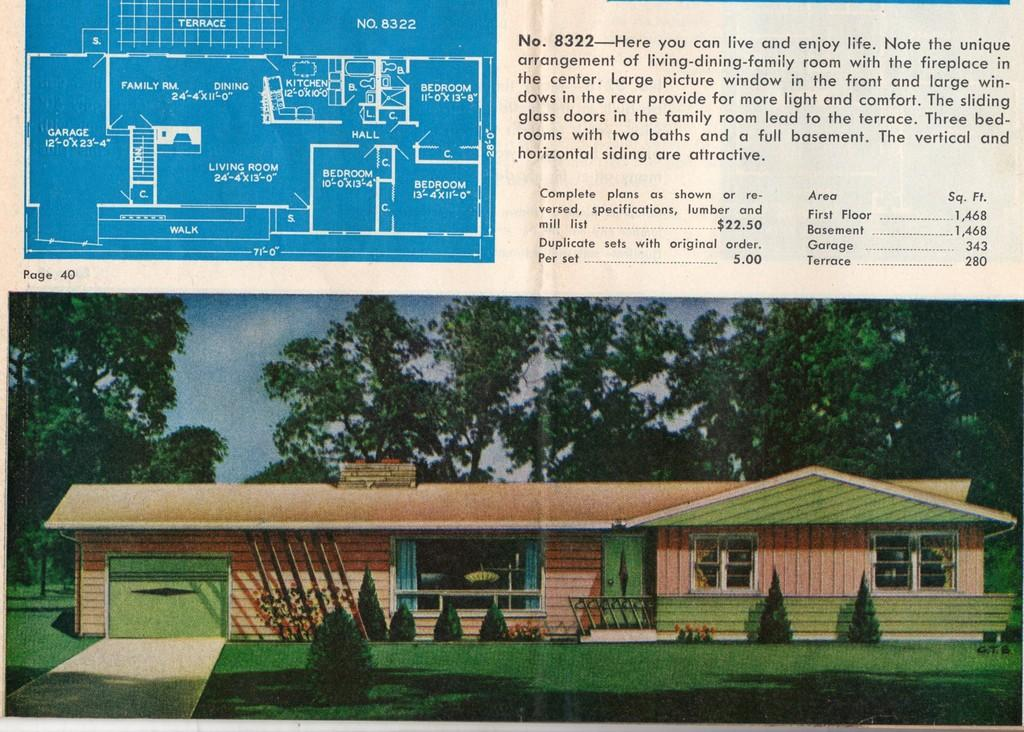What is the main subject of the image? The main subject of the image is a design of a building. Are there any words or letters in the image? Yes, there are texts in the image. What type of structure is depicted in the image? There is a picture of a building in the image. What type of vegetation can be seen in the image? Trees and plants are visible in the image. What is visible in the sky in the image? Clouds are in the sky in the image. Can you tell me how many hearts are beating in the image? There are no hearts visible in the image, so it is not possible to determine how many are beating. 